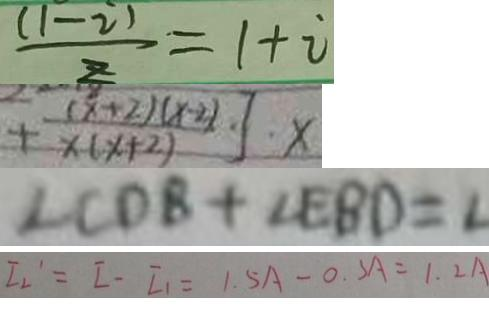Convert formula to latex. <formula><loc_0><loc_0><loc_500><loc_500>\frac { ( 1 - i ) } { z } = 1 + i 
 + \frac { ( x + 2 ) ( x - 2 ) } { x ( x + 2 ) } ] \cdot x 
 \angle C D B + \angle E B D = 2 
 I 2 ^ { \prime } = I - I _ { 1 } = 1 . 5 A - 0 . 3 A = 1 . 2 A</formula> 